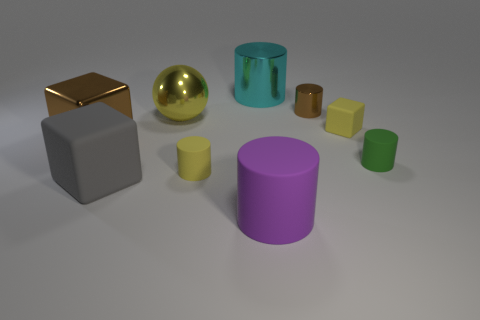Is the number of tiny red rubber things greater than the number of tiny cubes?
Give a very brief answer. No. There is a yellow thing that is left of the tiny brown shiny cylinder and in front of the large yellow shiny sphere; what size is it?
Your answer should be very brief. Small. There is another object that is the same color as the small shiny object; what is its material?
Offer a very short reply. Metal. Are there an equal number of large shiny spheres in front of the big gray block and small matte things?
Provide a succinct answer. No. Is the gray matte cube the same size as the yellow rubber block?
Provide a short and direct response. No. The large thing that is in front of the large brown cube and to the left of the large metal ball is what color?
Make the answer very short. Gray. There is a purple thing that is in front of the tiny yellow object behind the green rubber object; what is its material?
Give a very brief answer. Rubber. There is a brown object that is the same shape as the green object; what size is it?
Make the answer very short. Small. There is a large cylinder that is in front of the brown cube; is its color the same as the sphere?
Offer a terse response. No. Is the number of blocks less than the number of tiny objects?
Your response must be concise. Yes. 